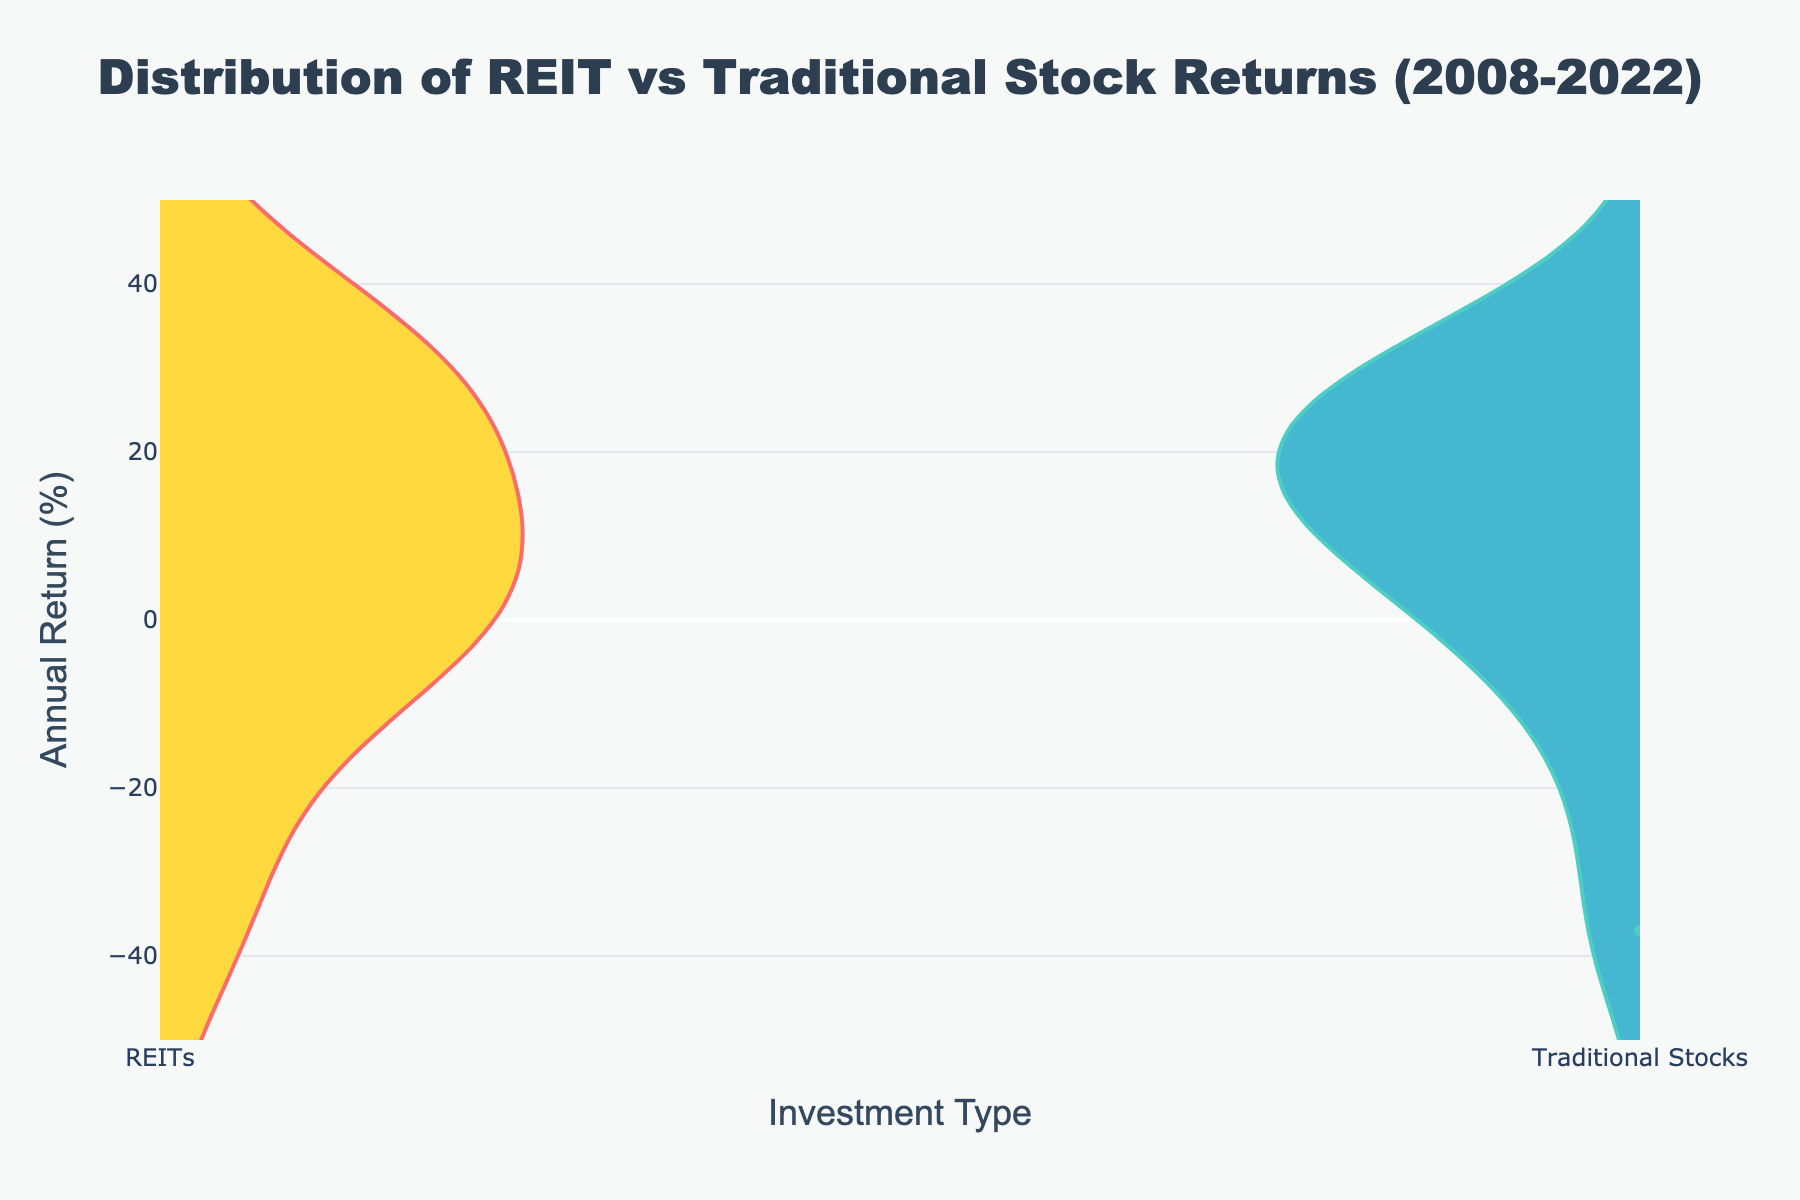What's the title of the plot? The title is located at the top center of the plot. It reads 'Distribution of REIT vs Traditional Stock Returns (2008-2022).'
Answer: 'Distribution of REIT vs Traditional Stock Returns (2008-2022)' What are the x-axis and y-axis titles in the plot? The x-axis title is 'Investment Type,' while the y-axis title is 'Annual Return (%).' These titles are found below the x-axis and to the left of the y-axis respectively.
Answer: 'Investment Type' and 'Annual Return (%)' Which investment type shows a broader range of returns? By observing the spread of the violin plots, we can see that the REITs plot is wider, indicating a broader range of returns compared to Traditional Stocks.
Answer: REITs What colors represent REITs and Traditional Stocks in the plot? The REITs are represented by the red and yellow colors, while Traditional Stocks are shown in teal and blue colors. This is seen by looking at the plot's color-coding.
Answer: Red and yellow for REITs, teal and blue for Traditional Stocks Which investment type appears to have more variability in returns over the years? By observing the width and spread of the violin plots, the REITs have a wider distribution, suggesting more variability in returns compared to Traditional Stocks.
Answer: REITs What is the highest annual return shown in the plot, and for which investment type? Visually examining the top of the violin plots, the highest annual return is seen for REITs, reaching around 41.29%.
Answer: 41.29% for REITs Which investment category experienced more negative returns? By observing the lower end of the violin plots, REITs experienced more negative returns, with values reaching down to approximately -38.05%.
Answer: REITs Between REITs and Traditional Stocks, which had a higher median annual return? Examining the central tendency marked by the wider parts of the violin plots, Traditional Stocks appear to have a higher median return as their thicker part is above that of REITs.
Answer: Traditional Stocks In which investment type did returns mostly stay within a narrower band? The violin plot for Traditional Stocks is more concentrated and narrower, indicating returns mostly stayed within a narrower band.
Answer: Traditional Stocks 